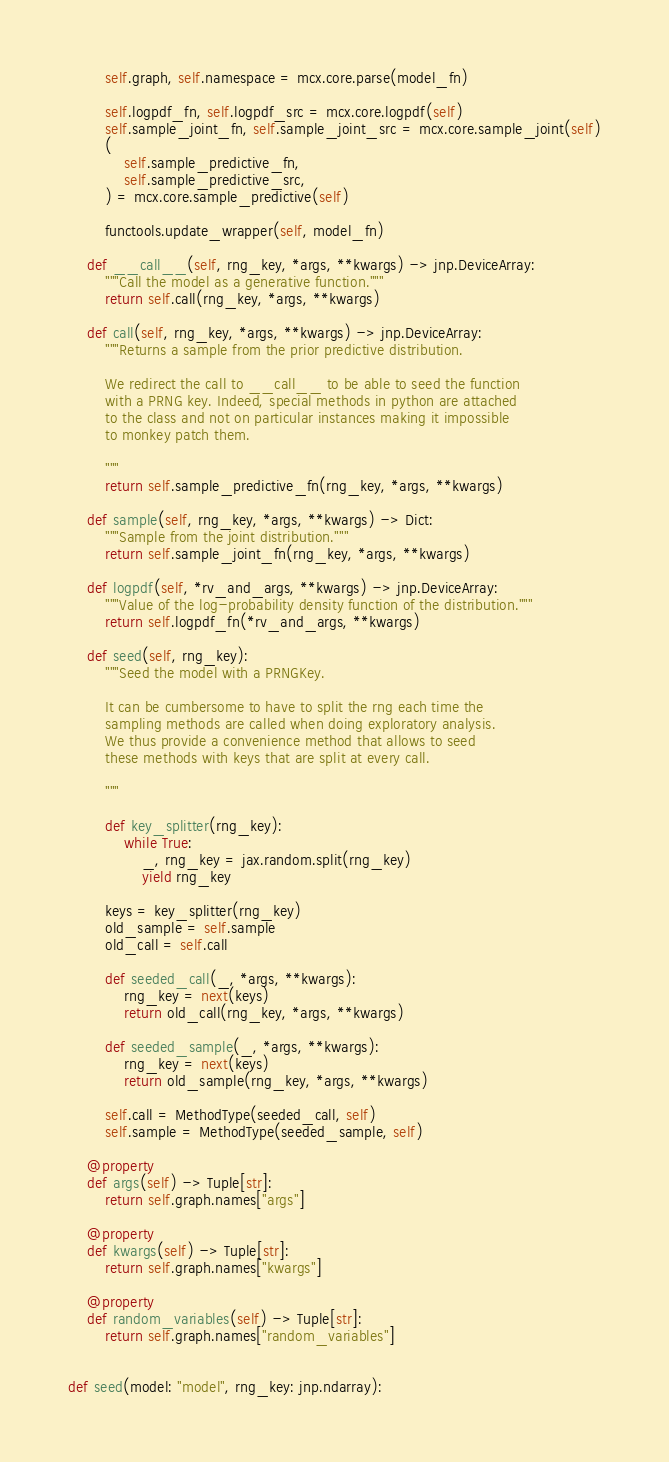Convert code to text. <code><loc_0><loc_0><loc_500><loc_500><_Python_>        self.graph, self.namespace = mcx.core.parse(model_fn)

        self.logpdf_fn, self.logpdf_src = mcx.core.logpdf(self)
        self.sample_joint_fn, self.sample_joint_src = mcx.core.sample_joint(self)
        (
            self.sample_predictive_fn,
            self.sample_predictive_src,
        ) = mcx.core.sample_predictive(self)

        functools.update_wrapper(self, model_fn)

    def __call__(self, rng_key, *args, **kwargs) -> jnp.DeviceArray:
        """Call the model as a generative function."""
        return self.call(rng_key, *args, **kwargs)

    def call(self, rng_key, *args, **kwargs) -> jnp.DeviceArray:
        """Returns a sample from the prior predictive distribution.

        We redirect the call to __call__ to be able to seed the function
        with a PRNG key. Indeed, special methods in python are attached
        to the class and not on particular instances making it impossible
        to monkey patch them.

        """
        return self.sample_predictive_fn(rng_key, *args, **kwargs)

    def sample(self, rng_key, *args, **kwargs) -> Dict:
        """Sample from the joint distribution."""
        return self.sample_joint_fn(rng_key, *args, **kwargs)

    def logpdf(self, *rv_and_args, **kwargs) -> jnp.DeviceArray:
        """Value of the log-probability density function of the distribution."""
        return self.logpdf_fn(*rv_and_args, **kwargs)

    def seed(self, rng_key):
        """Seed the model with a PRNGKey.

        It can be cumbersome to have to split the rng each time the
        sampling methods are called when doing exploratory analysis.
        We thus provide a convenience method that allows to seed
        these methods with keys that are split at every call.

        """

        def key_splitter(rng_key):
            while True:
                _, rng_key = jax.random.split(rng_key)
                yield rng_key

        keys = key_splitter(rng_key)
        old_sample = self.sample
        old_call = self.call

        def seeded_call(_, *args, **kwargs):
            rng_key = next(keys)
            return old_call(rng_key, *args, **kwargs)

        def seeded_sample(_, *args, **kwargs):
            rng_key = next(keys)
            return old_sample(rng_key, *args, **kwargs)

        self.call = MethodType(seeded_call, self)
        self.sample = MethodType(seeded_sample, self)

    @property
    def args(self) -> Tuple[str]:
        return self.graph.names["args"]

    @property
    def kwargs(self) -> Tuple[str]:
        return self.graph.names["kwargs"]

    @property
    def random_variables(self) -> Tuple[str]:
        return self.graph.names["random_variables"]


def seed(model: "model", rng_key: jnp.ndarray):</code> 